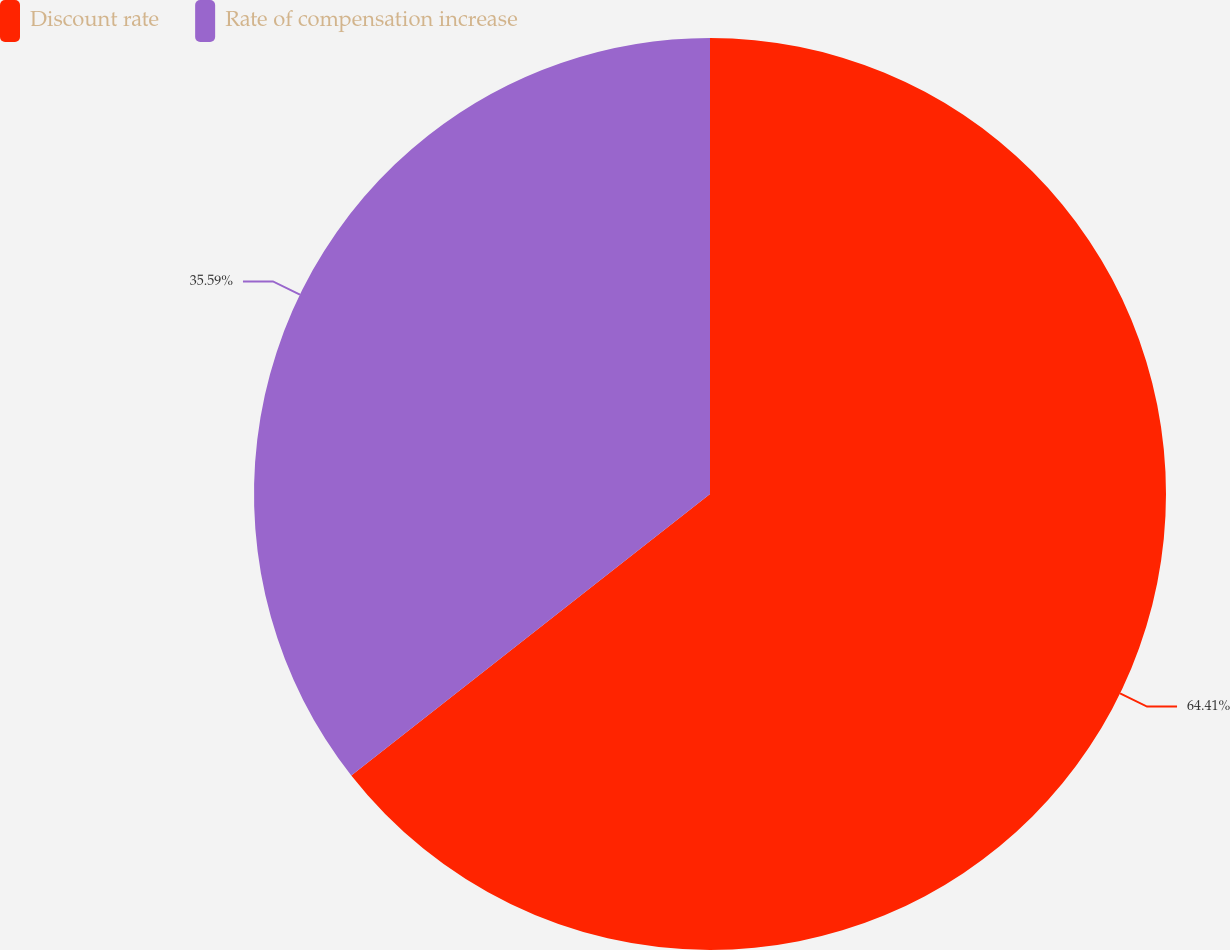Convert chart. <chart><loc_0><loc_0><loc_500><loc_500><pie_chart><fcel>Discount rate<fcel>Rate of compensation increase<nl><fcel>64.41%<fcel>35.59%<nl></chart> 